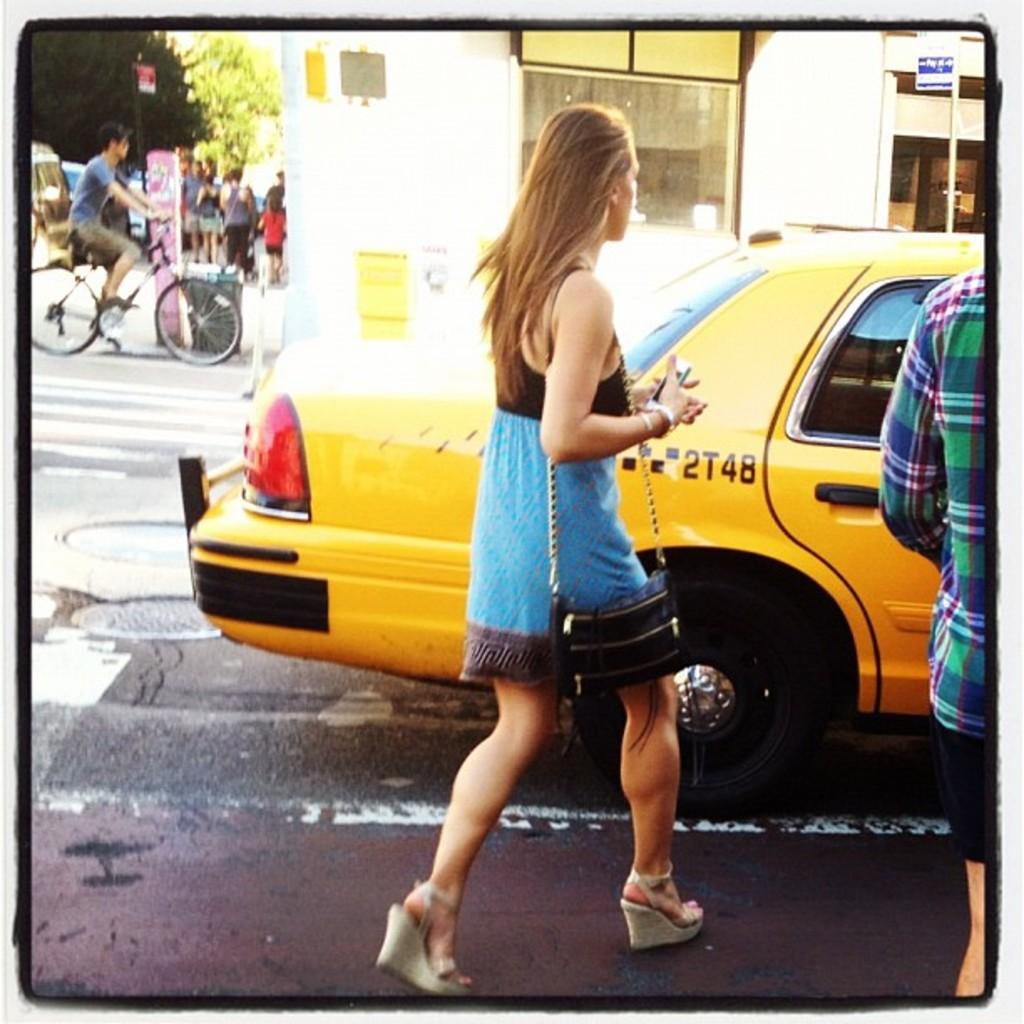<image>
Offer a succinct explanation of the picture presented. A woman run towards a taxi cab with 2T4B on its side. 